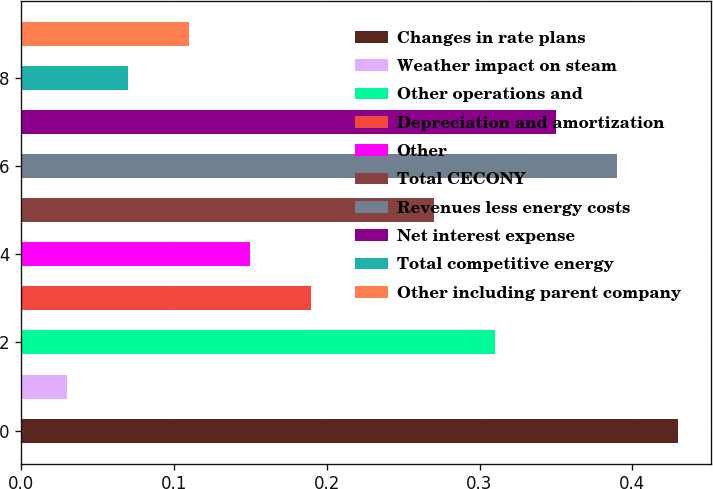<chart> <loc_0><loc_0><loc_500><loc_500><bar_chart><fcel>Changes in rate plans<fcel>Weather impact on steam<fcel>Other operations and<fcel>Depreciation and amortization<fcel>Other<fcel>Total CECONY<fcel>Revenues less energy costs<fcel>Net interest expense<fcel>Total competitive energy<fcel>Other including parent company<nl><fcel>0.43<fcel>0.03<fcel>0.31<fcel>0.19<fcel>0.15<fcel>0.27<fcel>0.39<fcel>0.35<fcel>0.07<fcel>0.11<nl></chart> 